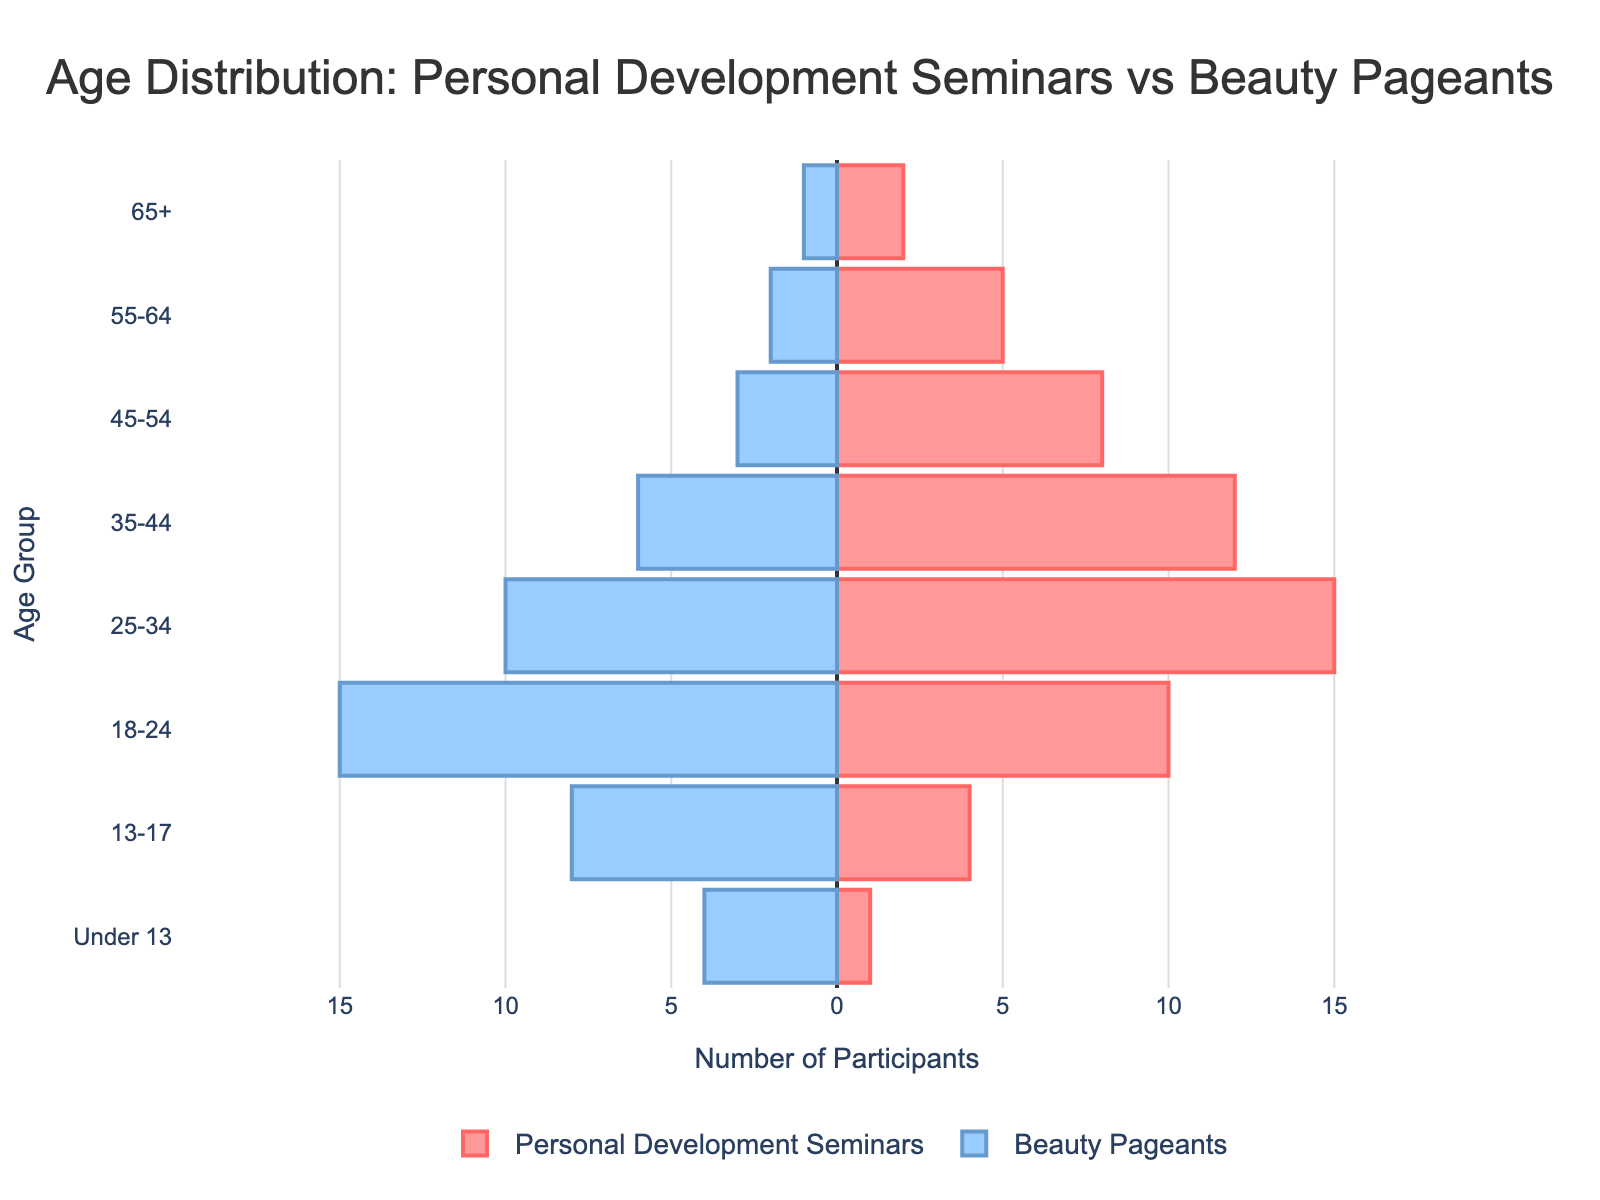What is the age group with the highest attendance in personal development seminars? Looking at the figure, the age group with the longest bar for personal development seminars represents the highest attendance. This is the 25-34 age group.
Answer: 25-34 Which age group sees the least attendance in beauty pageants? By examining the figure, the age group with the smallest negative bar for beauty pageants, representing the lowest attendance, is the 65+ age group.
Answer: 65+ How do the participation numbers of the 13-17 age group compare between personal development seminars and beauty pageants? The figure shows that the 13-17 age group has a bar length of 4 for personal development seminars and a bar length of 8 (negative) for beauty pageants. They participate more in beauty pageants than in personal development seminars.
Answer: More in beauty pageants What is the total participation number in personal development seminars for those aged 45 and above? Summing the values for those aged 45-54, 55-64, and 65+ in personal development seminars: 8 + 5 + 2 = 15.
Answer: 15 Which age group has a significantly higher attendance in beauty pageants compared to personal development seminars? The figure shows that the largest difference is in the 18-24 age group, with a bar of 10 for personal development seminars and -15 for beauty pageants. This group has significantly higher attendance in beauty pageants.
Answer: 18-24 How does the participation of under 13-year-olds compare between the two types of events? From the pyramid, the bar for under 13 in personal development seminars is 1, whereas it is -4 for beauty pageants. More participants attend beauty pageants in this age group.
Answer: More in beauty pageants What is the combined total attendance of individuals aged 35-44 in both events? The figure shows 12 participants in personal development seminars and 6 (negative) in beauty pageants for the 35-44 age group. Adding these gives 12 + 6 = 18.
Answer: 18 Which age group has equal participation in both personal development seminars and beauty pageants? Observing the figure, no age group has equal participation in both events. Every age group has differing lengths of bars.
Answer: None 